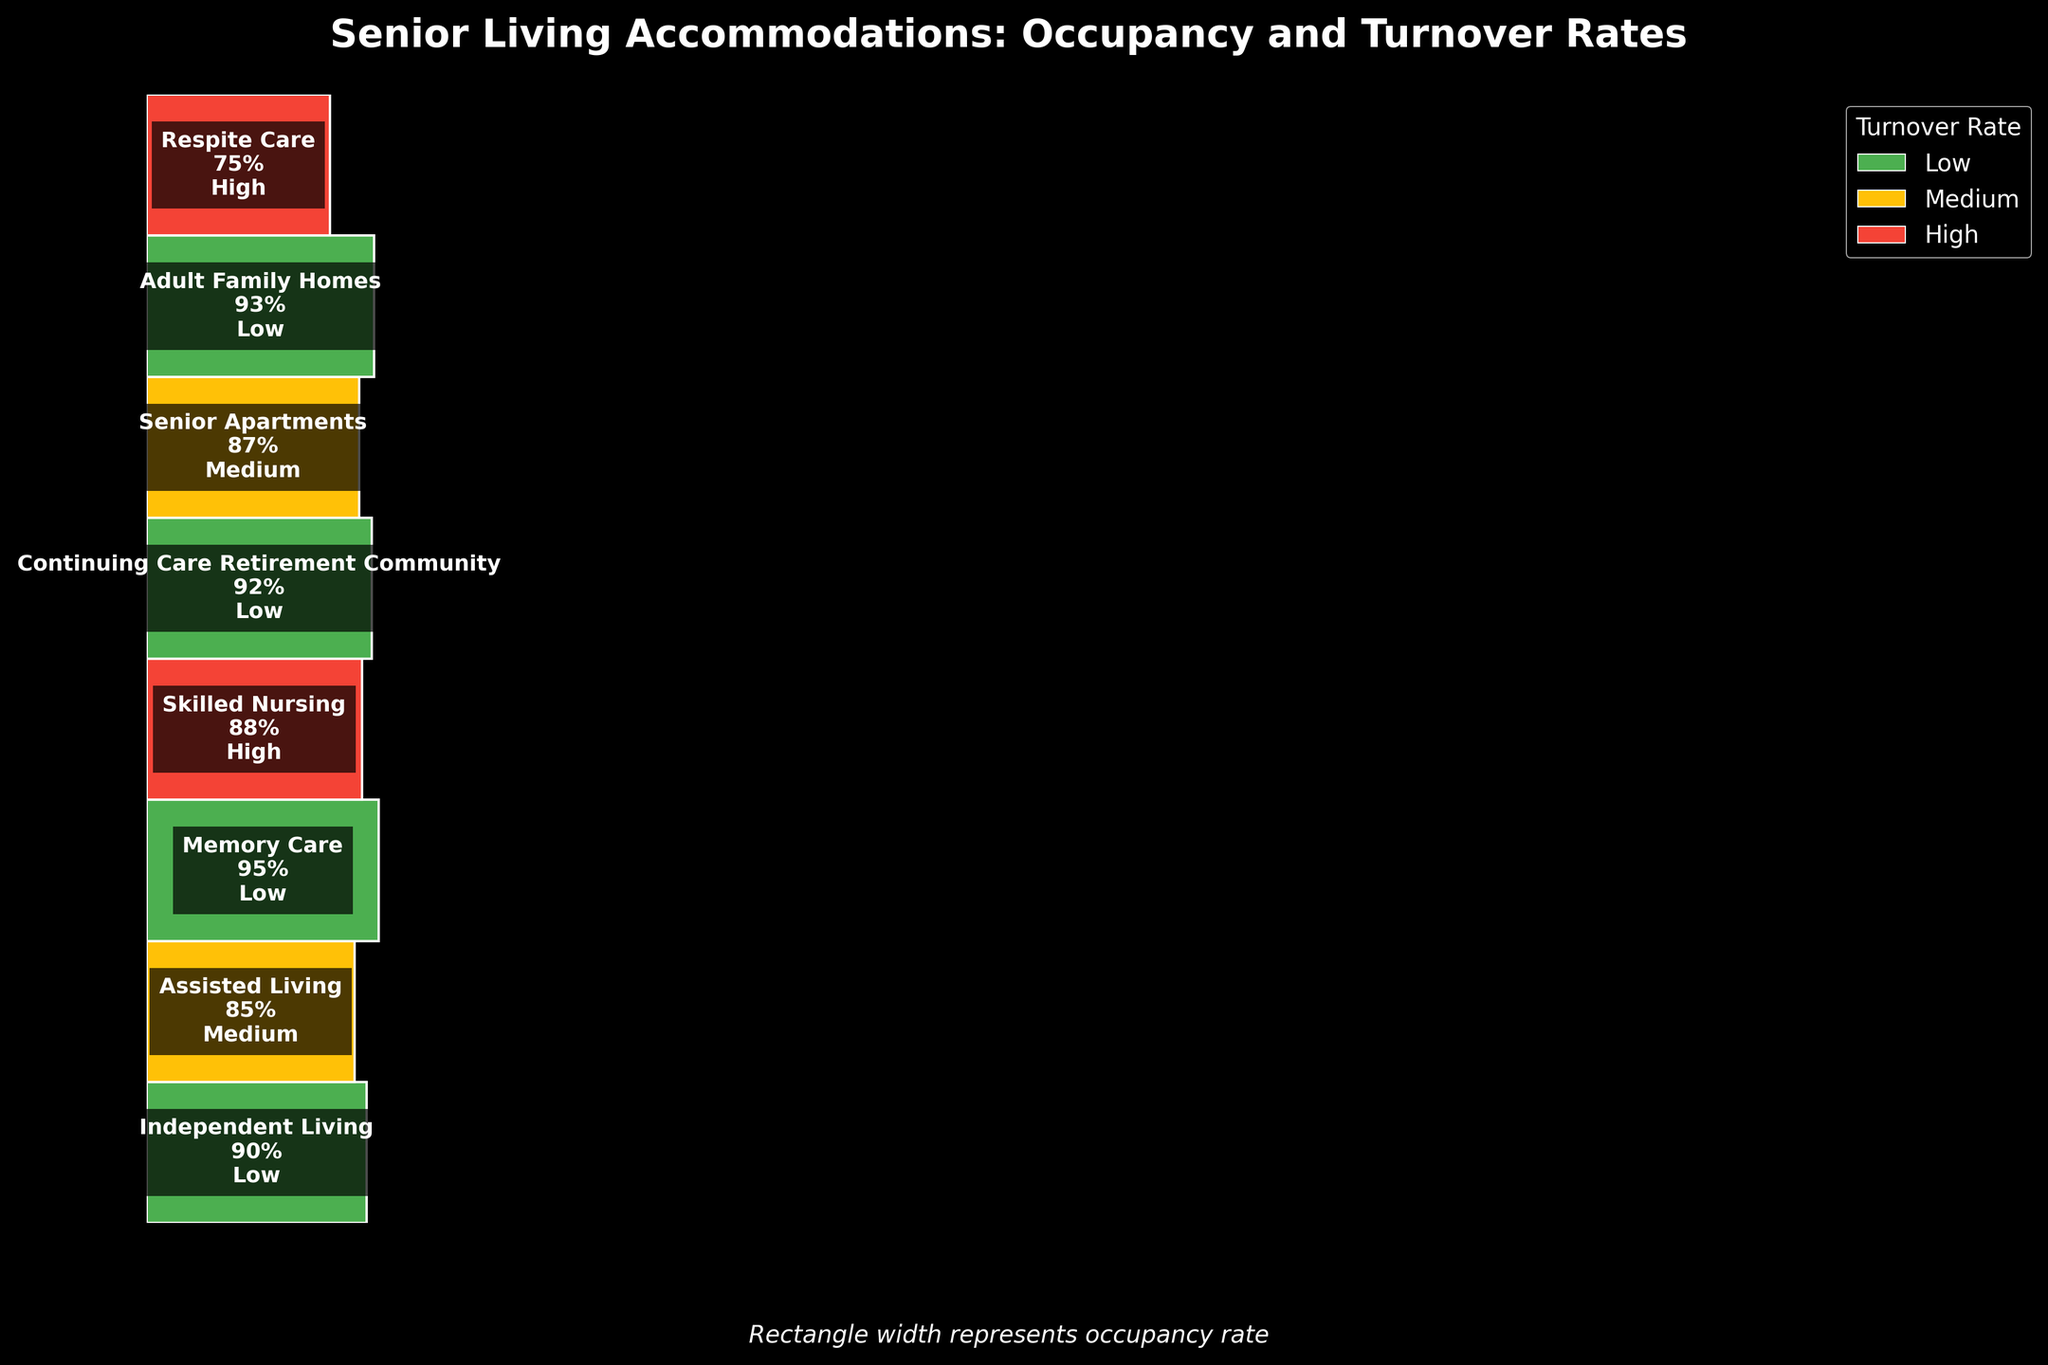What is the title of the figure? The title can often be found at the top of the plot and is used to briefly describe the content or purpose of the plot. By looking at the top of this figure, we can clearly see the title.
Answer: Senior Living Accommodations: Occupancy and Turnover Rates How many types of senior living accommodations are displayed in the figure? This can be determined by counting the number of different categories listed in the plot. Each accommodation type is represented by a separate rectangle.
Answer: 8 Which accommodation type has the highest occupancy rate? By observing the width of the rectangles, the wider the rectangle, the higher the occupancy rate. The accommodation type with the widest rectangle represents the highest occupancy rate.
Answer: Memory Care Which accommodation type has the lowest occupancy rate, and what is that rate? Similar to finding the highest occupancy rate, we look for the narrowest rectangle to find the lowest occupancy rate, and this width corresponds to the percentage shown within that rectangle.
Answer: Respite Care, 75% Compare the occupancy rates of Assisted Living and Skilled Nursing. Which one is higher? By visually comparing the widths of the rectangles for Assisted Living and Skilled Nursing, one can determine which rectangle is wider, indicating a higher occupancy rate.
Answer: Assisted Living What is the color representing high turnover rate in the plot? Color-coding is used in the plot to represent different turnover rates. By looking at the legend, we can identify the color associated with a high turnover rate.
Answer: Red Calculate the average occupancy rate of Independent Living, Assisted Living, and Senior Apartments. Sum the occupancy rates for these accommodations and divide by the number of accommodations. The occupancy rates are 90%, 85%, and 87%. (90 + 85 + 87) / 3 = 262 / 3 = 87.33%
Answer: 87.33% Which accommodation type has a low turnover rate and the second highest occupancy rate? First, find all accommodations with a low turnover rate by looking at the corresponding colors (green). Then, among those, identify which has the second widest rectangle.
Answer: Continuing Care Retirement Community Compare the turnover rates of Adult Family Homes and Respite Care. Which one has a higher turnover rate? By looking at the color of the rectangles for Adult Family Homes and Respite Care, we can determine which turnover rate is higher based on the color coding.
Answer: Respite Care What is the combined occupancy rate for Memory Care and Independent Living? Add the individual occupancy rates of Memory Care and Independent Living (95% and 90% respectively). 95 + 90 = 185%
Answer: 185% 